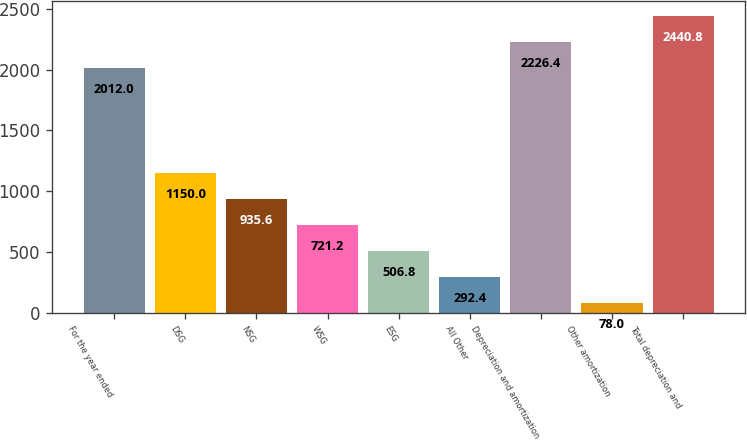Convert chart to OTSL. <chart><loc_0><loc_0><loc_500><loc_500><bar_chart><fcel>For the year ended<fcel>DSG<fcel>NSG<fcel>WSG<fcel>ESG<fcel>All Other<fcel>Depreciation and amortization<fcel>Other amortization<fcel>Total depreciation and<nl><fcel>2012<fcel>1150<fcel>935.6<fcel>721.2<fcel>506.8<fcel>292.4<fcel>2226.4<fcel>78<fcel>2440.8<nl></chart> 